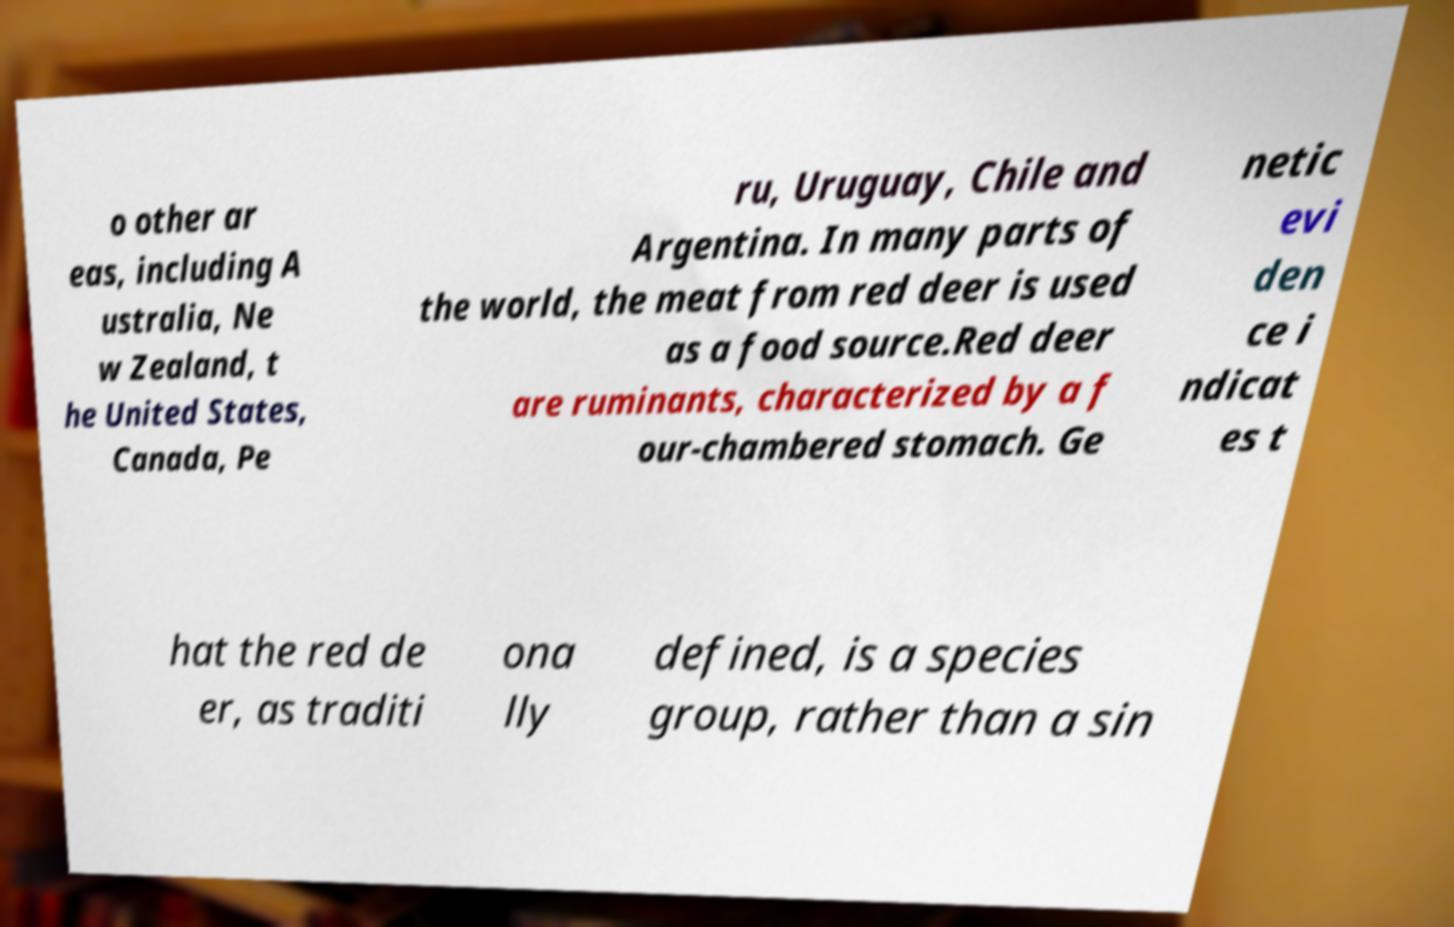Can you read and provide the text displayed in the image?This photo seems to have some interesting text. Can you extract and type it out for me? o other ar eas, including A ustralia, Ne w Zealand, t he United States, Canada, Pe ru, Uruguay, Chile and Argentina. In many parts of the world, the meat from red deer is used as a food source.Red deer are ruminants, characterized by a f our-chambered stomach. Ge netic evi den ce i ndicat es t hat the red de er, as traditi ona lly defined, is a species group, rather than a sin 